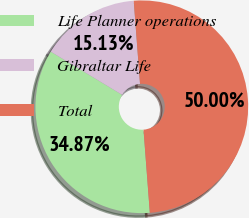Convert chart to OTSL. <chart><loc_0><loc_0><loc_500><loc_500><pie_chart><fcel>Life Planner operations<fcel>Gibraltar Life<fcel>Total<nl><fcel>34.87%<fcel>15.13%<fcel>50.0%<nl></chart> 